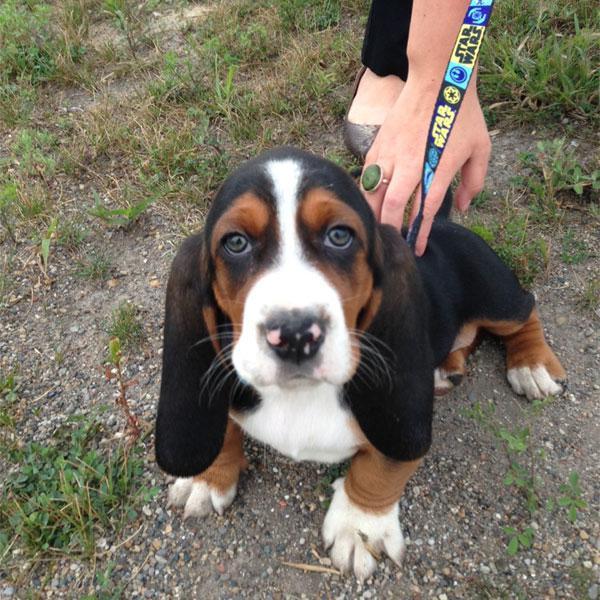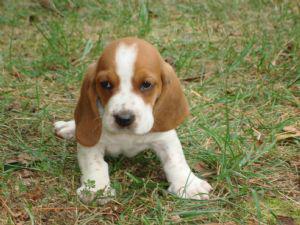The first image is the image on the left, the second image is the image on the right. Evaluate the accuracy of this statement regarding the images: "One image shows a basset hound being touched by a human hand.". Is it true? Answer yes or no. Yes. The first image is the image on the left, the second image is the image on the right. For the images shown, is this caption "One of the dogs is right next to a human, and being touched by the human." true? Answer yes or no. Yes. 